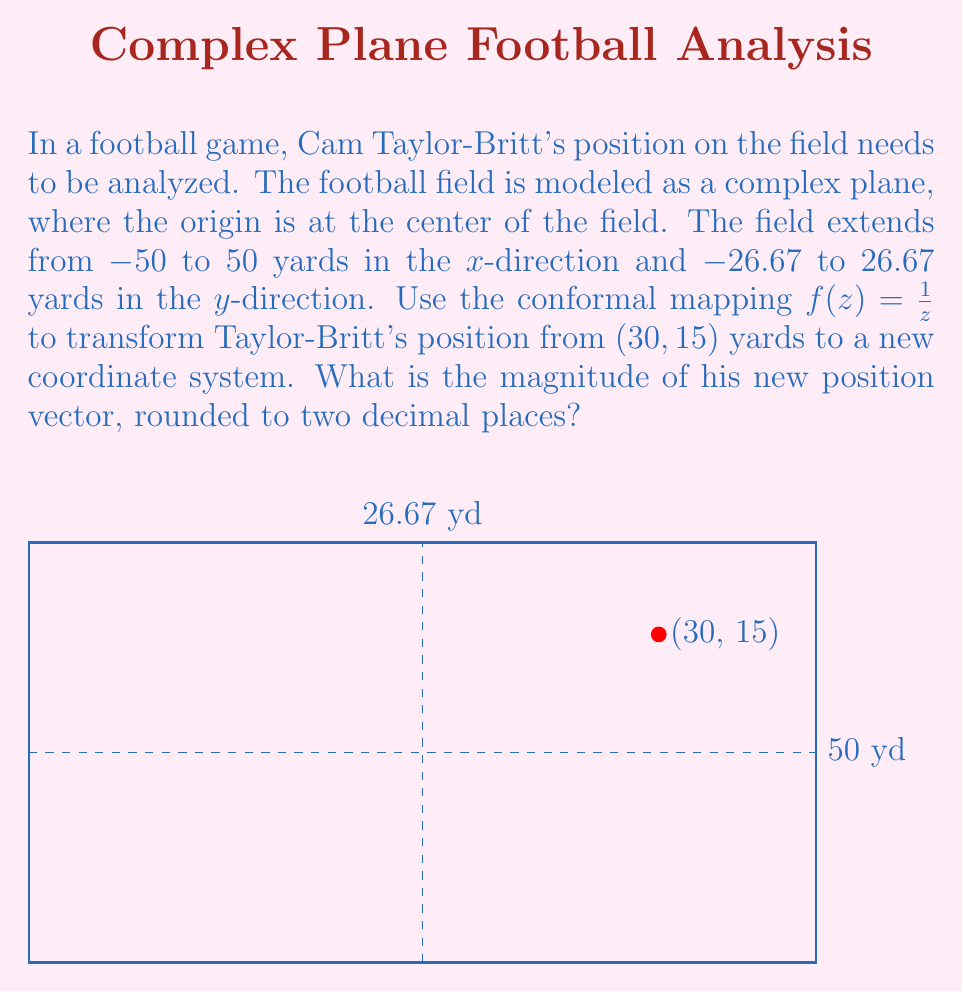Can you answer this question? Let's approach this step-by-step:

1) First, we need to convert the given position $(30, 15)$ to a complex number. In the complex plane, this point is represented as:

   $z = 30 + 15i$

2) Now, we apply the conformal mapping $f(z) = \frac{1}{z}$ to this point:

   $f(z) = \frac{1}{30 + 15i}$

3) To simplify this, we multiply both numerator and denominator by the complex conjugate of the denominator:

   $f(z) = \frac{1}{30 + 15i} \cdot \frac{30 - 15i}{30 - 15i} = \frac{30 - 15i}{(30)^2 + (15)^2} = \frac{30 - 15i}{1125}$

4) Simplifying further:

   $f(z) = \frac{2}{75} - \frac{1}{75}i$

5) To find the magnitude of this new position vector, we use the formula $|a + bi| = \sqrt{a^2 + b^2}$:

   $|f(z)| = \sqrt{(\frac{2}{75})^2 + (-\frac{1}{75})^2}$

6) Simplifying under the square root:

   $|f(z)| = \sqrt{\frac{4}{5625} + \frac{1}{5625}} = \sqrt{\frac{5}{5625}} = \frac{\sqrt{5}}{75}$

7) Calculating this and rounding to two decimal places:

   $\frac{\sqrt{5}}{75} \approx 0.0298 \approx 0.03$
Answer: 0.03 